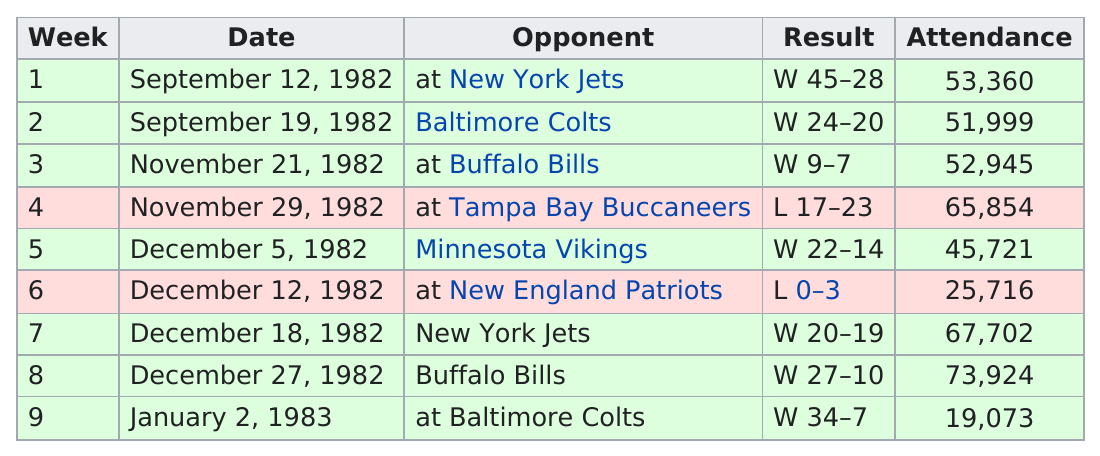Draw attention to some important aspects in this diagram. The total number of opponents is 9. The Miami Dolphins have achieved a record of three consecutive wins, a feat that demonstrates their exceptional skill and teamwork. The team that defeated the dolphins that was not the New England Patriots is the Tampa Bay Buccaneers. There were 53,360 attendees at the game on September 12th. The Miami Dolphins scored at least 20 points in six games this season. 